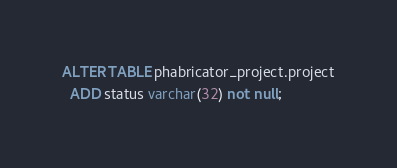Convert code to text. <code><loc_0><loc_0><loc_500><loc_500><_SQL_>ALTER TABLE phabricator_project.project
  ADD status varchar(32) not null;</code> 